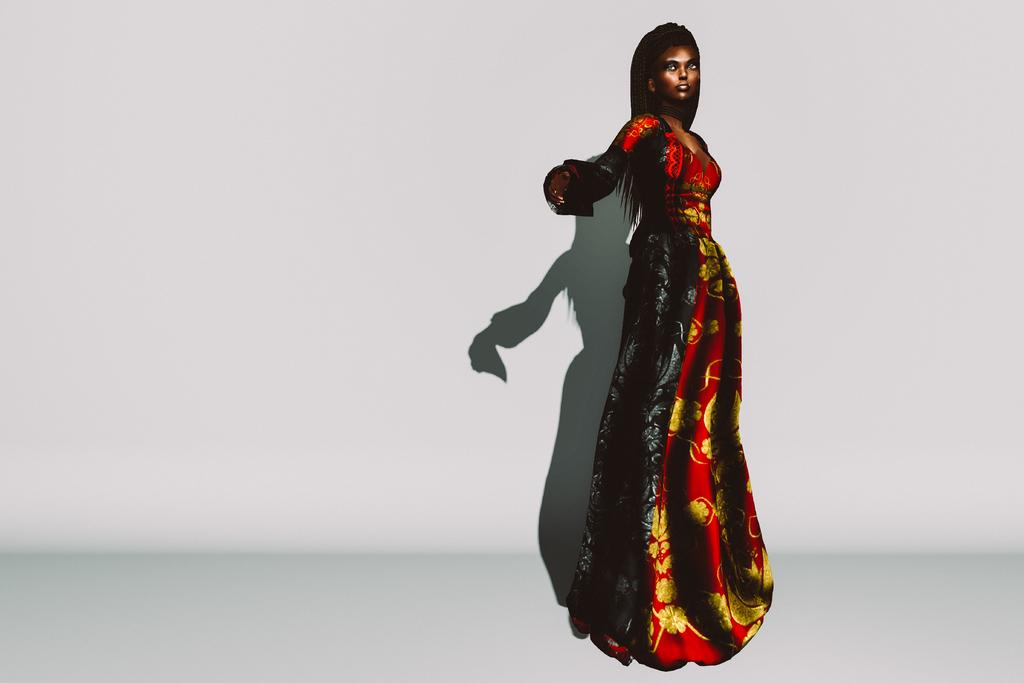What is the main subject of the image? There is an animated picture of a woman in the image. What color is the background of the image? The background of the image is white. How does the letter contribute to the comfort of the woman in the image? There is no letter present in the image, so it cannot contribute to the comfort of the woman. 